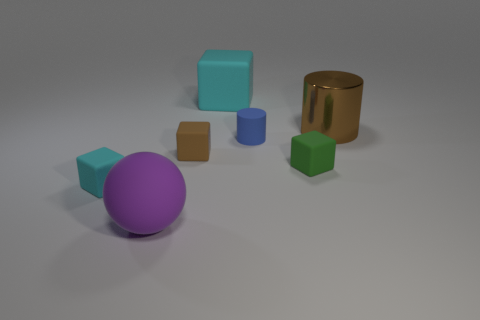Can you tell me about the colors used in this image? Certainly, the image showcases a variety of colors including a vivid purple on the sphere, a rich gold on the cylindrical object, and an array of cooler tones like cyan and light blue on the cubes, as well as a muted brown and green. The use of both warm and cool colors creates a balanced and harmonious composition. 